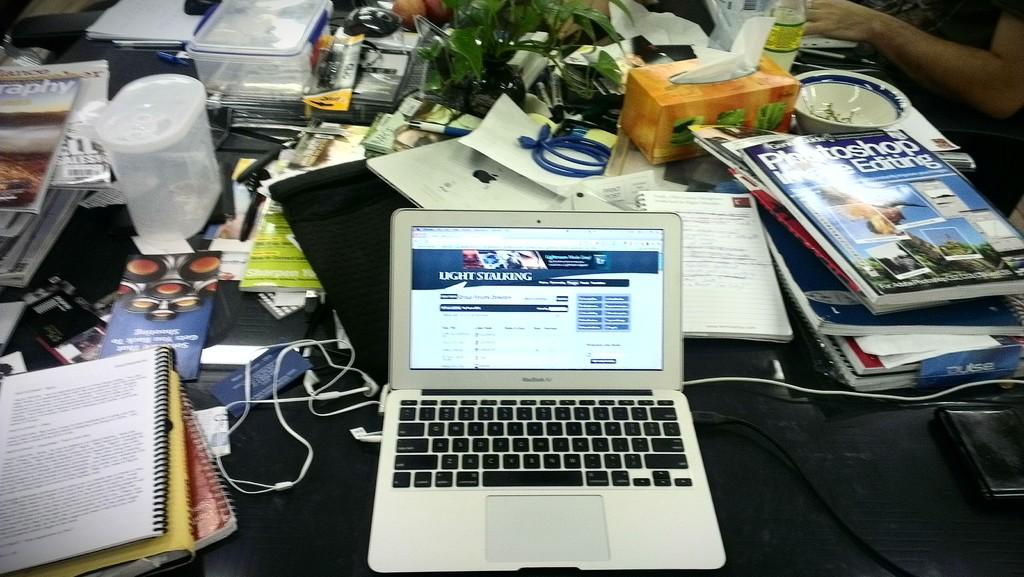<image>
Provide a brief description of the given image. A laptop displays a web page on photography techniques. 